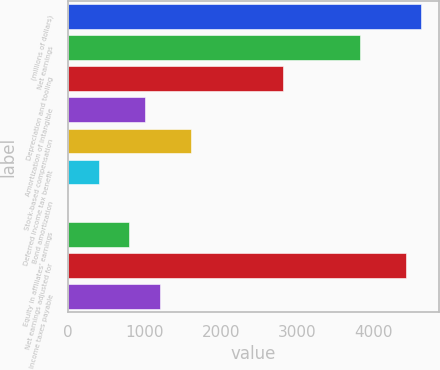<chart> <loc_0><loc_0><loc_500><loc_500><bar_chart><fcel>(millions of dollars)<fcel>Net earnings<fcel>Depreciation and tooling<fcel>Amortization of intangible<fcel>Stock-based compensation<fcel>Deferred income tax benefit<fcel>Bond amortization<fcel>Equity in affiliates' earnings<fcel>Net earnings adjusted for<fcel>Income taxes payable<nl><fcel>4620.71<fcel>3818.03<fcel>2814.68<fcel>1008.65<fcel>1610.66<fcel>406.64<fcel>5.3<fcel>807.98<fcel>4420.04<fcel>1209.32<nl></chart> 